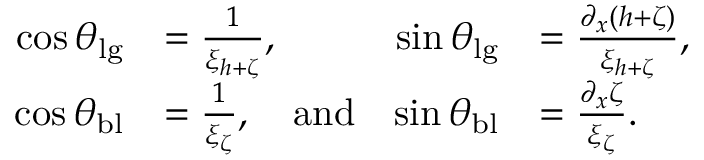Convert formula to latex. <formula><loc_0><loc_0><loc_500><loc_500>\begin{array} { r l r l } { \cos \theta _ { l g } } & { = \frac { 1 } { \xi _ { h + \zeta } } , } & { \sin \theta _ { l g } } & { = \frac { \partial _ { x } ( h + \zeta ) } { \xi _ { h + \zeta } } , } \\ { \cos \theta _ { b l } } & { = \frac { 1 } { \xi _ { \zeta } } , \quad a n d } & { \sin \theta _ { b l } } & { = \frac { \partial _ { x } \zeta } { \xi _ { \zeta } } . } \end{array}</formula> 